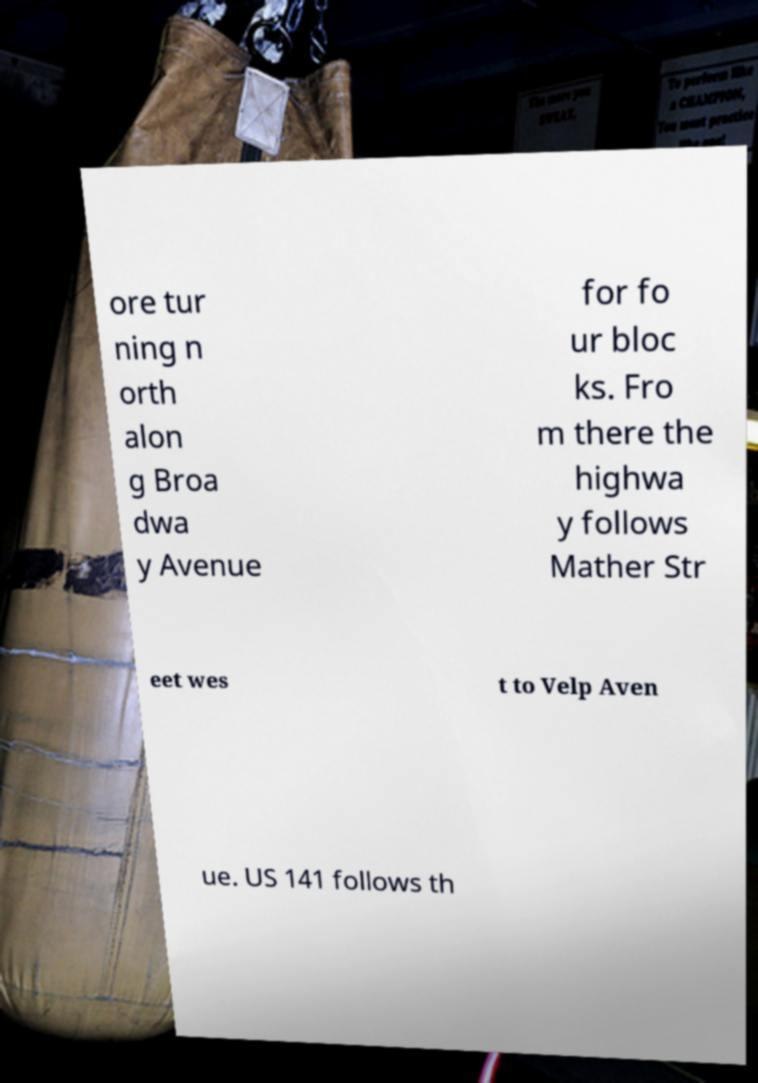Can you read and provide the text displayed in the image?This photo seems to have some interesting text. Can you extract and type it out for me? ore tur ning n orth alon g Broa dwa y Avenue for fo ur bloc ks. Fro m there the highwa y follows Mather Str eet wes t to Velp Aven ue. US 141 follows th 